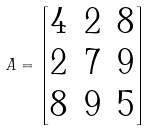Convert formula to latex. <formula><loc_0><loc_0><loc_500><loc_500>A = \left [ \begin{matrix} 4 & 2 & 8 \\ 2 & 7 & 9 \\ 8 & 9 & 5 \\ \end{matrix} \right ]</formula> 